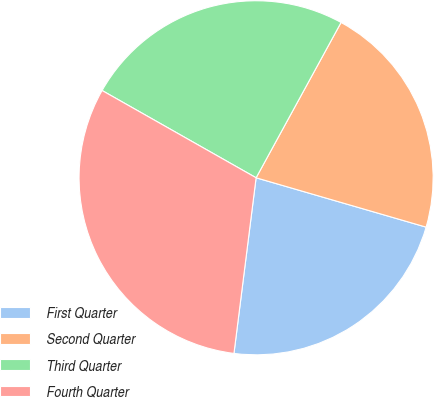<chart> <loc_0><loc_0><loc_500><loc_500><pie_chart><fcel>First Quarter<fcel>Second Quarter<fcel>Third Quarter<fcel>Fourth Quarter<nl><fcel>22.5%<fcel>21.53%<fcel>24.76%<fcel>31.21%<nl></chart> 